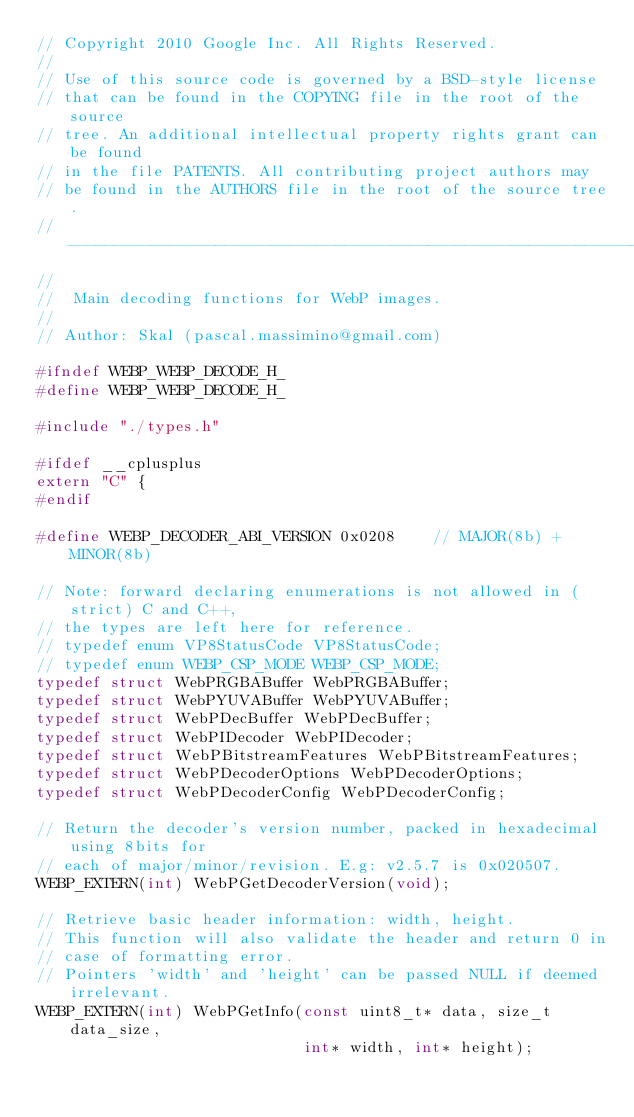<code> <loc_0><loc_0><loc_500><loc_500><_C_>// Copyright 2010 Google Inc. All Rights Reserved.
//
// Use of this source code is governed by a BSD-style license
// that can be found in the COPYING file in the root of the source
// tree. An additional intellectual property rights grant can be found
// in the file PATENTS. All contributing project authors may
// be found in the AUTHORS file in the root of the source tree.
// -----------------------------------------------------------------------------
//
//  Main decoding functions for WebP images.
//
// Author: Skal (pascal.massimino@gmail.com)

#ifndef WEBP_WEBP_DECODE_H_
#define WEBP_WEBP_DECODE_H_

#include "./types.h"

#ifdef __cplusplus
extern "C" {
#endif

#define WEBP_DECODER_ABI_VERSION 0x0208    // MAJOR(8b) + MINOR(8b)

// Note: forward declaring enumerations is not allowed in (strict) C and C++,
// the types are left here for reference.
// typedef enum VP8StatusCode VP8StatusCode;
// typedef enum WEBP_CSP_MODE WEBP_CSP_MODE;
typedef struct WebPRGBABuffer WebPRGBABuffer;
typedef struct WebPYUVABuffer WebPYUVABuffer;
typedef struct WebPDecBuffer WebPDecBuffer;
typedef struct WebPIDecoder WebPIDecoder;
typedef struct WebPBitstreamFeatures WebPBitstreamFeatures;
typedef struct WebPDecoderOptions WebPDecoderOptions;
typedef struct WebPDecoderConfig WebPDecoderConfig;

// Return the decoder's version number, packed in hexadecimal using 8bits for
// each of major/minor/revision. E.g: v2.5.7 is 0x020507.
WEBP_EXTERN(int) WebPGetDecoderVersion(void);

// Retrieve basic header information: width, height.
// This function will also validate the header and return 0 in
// case of formatting error.
// Pointers 'width' and 'height' can be passed NULL if deemed irrelevant.
WEBP_EXTERN(int) WebPGetInfo(const uint8_t* data, size_t data_size,
                             int* width, int* height);
</code> 